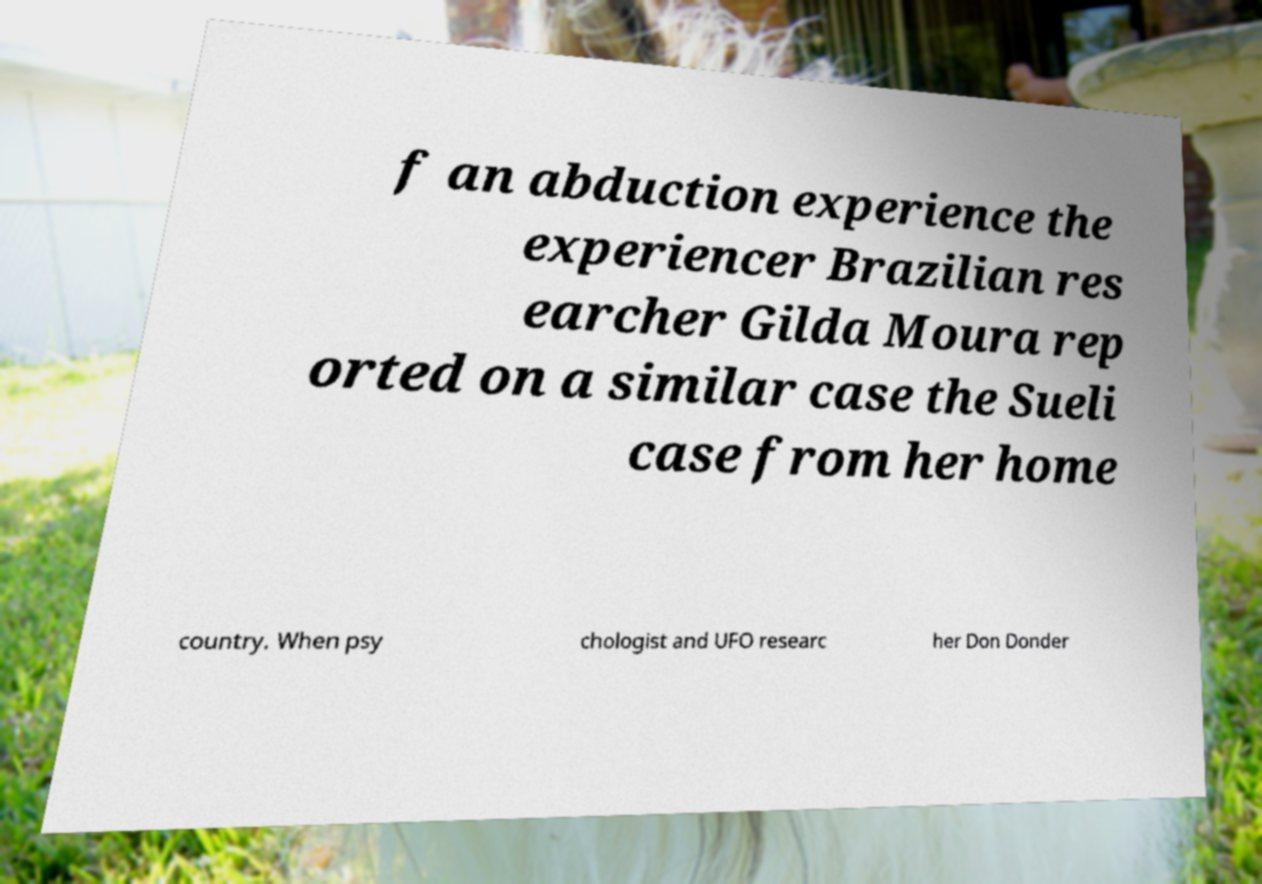Could you extract and type out the text from this image? f an abduction experience the experiencer Brazilian res earcher Gilda Moura rep orted on a similar case the Sueli case from her home country. When psy chologist and UFO researc her Don Donder 